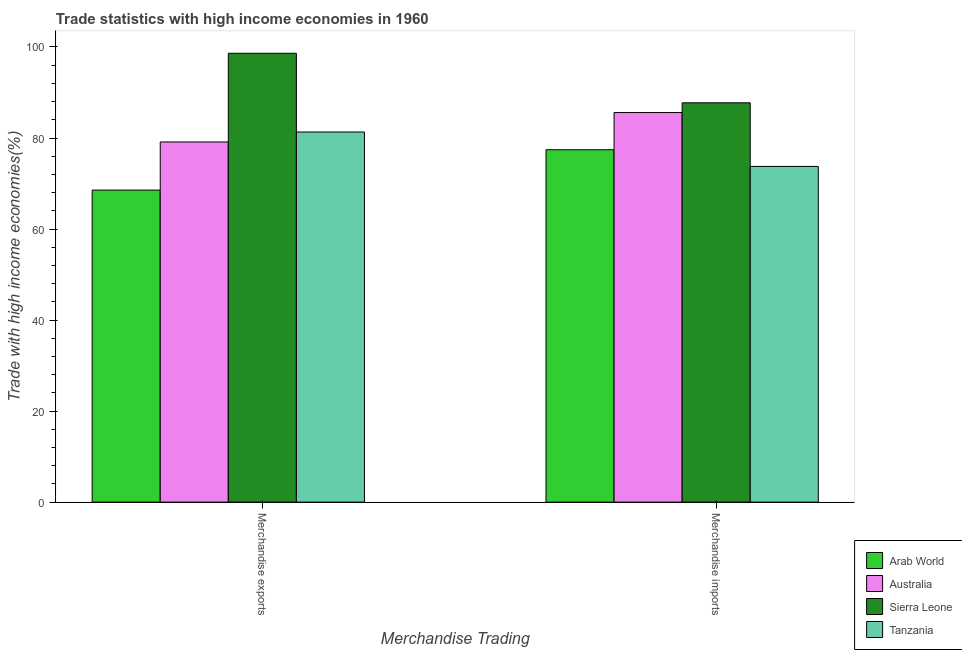How many groups of bars are there?
Provide a short and direct response. 2. How many bars are there on the 2nd tick from the right?
Your answer should be very brief. 4. What is the merchandise exports in Sierra Leone?
Give a very brief answer. 98.62. Across all countries, what is the maximum merchandise imports?
Offer a terse response. 87.74. Across all countries, what is the minimum merchandise exports?
Your response must be concise. 68.56. In which country was the merchandise imports maximum?
Provide a short and direct response. Sierra Leone. In which country was the merchandise imports minimum?
Provide a succinct answer. Tanzania. What is the total merchandise imports in the graph?
Offer a terse response. 324.53. What is the difference between the merchandise imports in Australia and that in Tanzania?
Offer a very short reply. 11.84. What is the difference between the merchandise imports in Sierra Leone and the merchandise exports in Tanzania?
Provide a short and direct response. 6.42. What is the average merchandise exports per country?
Offer a terse response. 81.91. What is the difference between the merchandise exports and merchandise imports in Tanzania?
Keep it short and to the point. 7.56. In how many countries, is the merchandise exports greater than 4 %?
Make the answer very short. 4. What is the ratio of the merchandise imports in Tanzania to that in Australia?
Ensure brevity in your answer.  0.86. Is the merchandise exports in Tanzania less than that in Sierra Leone?
Offer a very short reply. Yes. In how many countries, is the merchandise imports greater than the average merchandise imports taken over all countries?
Ensure brevity in your answer.  2. What does the 4th bar from the left in Merchandise imports represents?
Keep it short and to the point. Tanzania. What is the difference between two consecutive major ticks on the Y-axis?
Offer a terse response. 20. Does the graph contain grids?
Make the answer very short. No. Where does the legend appear in the graph?
Provide a succinct answer. Bottom right. What is the title of the graph?
Make the answer very short. Trade statistics with high income economies in 1960. Does "Sweden" appear as one of the legend labels in the graph?
Make the answer very short. No. What is the label or title of the X-axis?
Your response must be concise. Merchandise Trading. What is the label or title of the Y-axis?
Offer a terse response. Trade with high income economies(%). What is the Trade with high income economies(%) of Arab World in Merchandise exports?
Make the answer very short. 68.56. What is the Trade with high income economies(%) of Australia in Merchandise exports?
Your response must be concise. 79.13. What is the Trade with high income economies(%) of Sierra Leone in Merchandise exports?
Make the answer very short. 98.62. What is the Trade with high income economies(%) of Tanzania in Merchandise exports?
Ensure brevity in your answer.  81.32. What is the Trade with high income economies(%) in Arab World in Merchandise imports?
Provide a succinct answer. 77.43. What is the Trade with high income economies(%) of Australia in Merchandise imports?
Your answer should be compact. 85.6. What is the Trade with high income economies(%) in Sierra Leone in Merchandise imports?
Provide a short and direct response. 87.74. What is the Trade with high income economies(%) in Tanzania in Merchandise imports?
Offer a terse response. 73.76. Across all Merchandise Trading, what is the maximum Trade with high income economies(%) of Arab World?
Make the answer very short. 77.43. Across all Merchandise Trading, what is the maximum Trade with high income economies(%) in Australia?
Provide a succinct answer. 85.6. Across all Merchandise Trading, what is the maximum Trade with high income economies(%) of Sierra Leone?
Your answer should be compact. 98.62. Across all Merchandise Trading, what is the maximum Trade with high income economies(%) of Tanzania?
Your answer should be very brief. 81.32. Across all Merchandise Trading, what is the minimum Trade with high income economies(%) of Arab World?
Offer a very short reply. 68.56. Across all Merchandise Trading, what is the minimum Trade with high income economies(%) of Australia?
Ensure brevity in your answer.  79.13. Across all Merchandise Trading, what is the minimum Trade with high income economies(%) in Sierra Leone?
Your response must be concise. 87.74. Across all Merchandise Trading, what is the minimum Trade with high income economies(%) in Tanzania?
Offer a very short reply. 73.76. What is the total Trade with high income economies(%) in Arab World in the graph?
Your answer should be very brief. 145.99. What is the total Trade with high income economies(%) in Australia in the graph?
Provide a short and direct response. 164.73. What is the total Trade with high income economies(%) in Sierra Leone in the graph?
Give a very brief answer. 186.36. What is the total Trade with high income economies(%) of Tanzania in the graph?
Keep it short and to the point. 155.08. What is the difference between the Trade with high income economies(%) in Arab World in Merchandise exports and that in Merchandise imports?
Provide a succinct answer. -8.87. What is the difference between the Trade with high income economies(%) of Australia in Merchandise exports and that in Merchandise imports?
Offer a terse response. -6.47. What is the difference between the Trade with high income economies(%) of Sierra Leone in Merchandise exports and that in Merchandise imports?
Provide a succinct answer. 10.88. What is the difference between the Trade with high income economies(%) in Tanzania in Merchandise exports and that in Merchandise imports?
Ensure brevity in your answer.  7.56. What is the difference between the Trade with high income economies(%) of Arab World in Merchandise exports and the Trade with high income economies(%) of Australia in Merchandise imports?
Keep it short and to the point. -17.04. What is the difference between the Trade with high income economies(%) of Arab World in Merchandise exports and the Trade with high income economies(%) of Sierra Leone in Merchandise imports?
Make the answer very short. -19.18. What is the difference between the Trade with high income economies(%) in Arab World in Merchandise exports and the Trade with high income economies(%) in Tanzania in Merchandise imports?
Give a very brief answer. -5.2. What is the difference between the Trade with high income economies(%) of Australia in Merchandise exports and the Trade with high income economies(%) of Sierra Leone in Merchandise imports?
Your answer should be very brief. -8.61. What is the difference between the Trade with high income economies(%) in Australia in Merchandise exports and the Trade with high income economies(%) in Tanzania in Merchandise imports?
Give a very brief answer. 5.37. What is the difference between the Trade with high income economies(%) in Sierra Leone in Merchandise exports and the Trade with high income economies(%) in Tanzania in Merchandise imports?
Provide a succinct answer. 24.86. What is the average Trade with high income economies(%) of Arab World per Merchandise Trading?
Make the answer very short. 72.99. What is the average Trade with high income economies(%) of Australia per Merchandise Trading?
Your answer should be very brief. 82.37. What is the average Trade with high income economies(%) in Sierra Leone per Merchandise Trading?
Provide a short and direct response. 93.18. What is the average Trade with high income economies(%) of Tanzania per Merchandise Trading?
Provide a short and direct response. 77.54. What is the difference between the Trade with high income economies(%) of Arab World and Trade with high income economies(%) of Australia in Merchandise exports?
Give a very brief answer. -10.57. What is the difference between the Trade with high income economies(%) of Arab World and Trade with high income economies(%) of Sierra Leone in Merchandise exports?
Keep it short and to the point. -30.06. What is the difference between the Trade with high income economies(%) in Arab World and Trade with high income economies(%) in Tanzania in Merchandise exports?
Your response must be concise. -12.76. What is the difference between the Trade with high income economies(%) in Australia and Trade with high income economies(%) in Sierra Leone in Merchandise exports?
Offer a terse response. -19.49. What is the difference between the Trade with high income economies(%) of Australia and Trade with high income economies(%) of Tanzania in Merchandise exports?
Keep it short and to the point. -2.19. What is the difference between the Trade with high income economies(%) of Sierra Leone and Trade with high income economies(%) of Tanzania in Merchandise exports?
Make the answer very short. 17.3. What is the difference between the Trade with high income economies(%) in Arab World and Trade with high income economies(%) in Australia in Merchandise imports?
Provide a short and direct response. -8.18. What is the difference between the Trade with high income economies(%) of Arab World and Trade with high income economies(%) of Sierra Leone in Merchandise imports?
Provide a succinct answer. -10.32. What is the difference between the Trade with high income economies(%) of Arab World and Trade with high income economies(%) of Tanzania in Merchandise imports?
Your answer should be very brief. 3.67. What is the difference between the Trade with high income economies(%) of Australia and Trade with high income economies(%) of Sierra Leone in Merchandise imports?
Your response must be concise. -2.14. What is the difference between the Trade with high income economies(%) of Australia and Trade with high income economies(%) of Tanzania in Merchandise imports?
Your response must be concise. 11.84. What is the difference between the Trade with high income economies(%) in Sierra Leone and Trade with high income economies(%) in Tanzania in Merchandise imports?
Give a very brief answer. 13.98. What is the ratio of the Trade with high income economies(%) of Arab World in Merchandise exports to that in Merchandise imports?
Provide a succinct answer. 0.89. What is the ratio of the Trade with high income economies(%) in Australia in Merchandise exports to that in Merchandise imports?
Provide a short and direct response. 0.92. What is the ratio of the Trade with high income economies(%) of Sierra Leone in Merchandise exports to that in Merchandise imports?
Your answer should be very brief. 1.12. What is the ratio of the Trade with high income economies(%) of Tanzania in Merchandise exports to that in Merchandise imports?
Offer a very short reply. 1.1. What is the difference between the highest and the second highest Trade with high income economies(%) in Arab World?
Give a very brief answer. 8.87. What is the difference between the highest and the second highest Trade with high income economies(%) in Australia?
Your answer should be compact. 6.47. What is the difference between the highest and the second highest Trade with high income economies(%) of Sierra Leone?
Ensure brevity in your answer.  10.88. What is the difference between the highest and the second highest Trade with high income economies(%) of Tanzania?
Make the answer very short. 7.56. What is the difference between the highest and the lowest Trade with high income economies(%) in Arab World?
Make the answer very short. 8.87. What is the difference between the highest and the lowest Trade with high income economies(%) in Australia?
Keep it short and to the point. 6.47. What is the difference between the highest and the lowest Trade with high income economies(%) of Sierra Leone?
Ensure brevity in your answer.  10.88. What is the difference between the highest and the lowest Trade with high income economies(%) in Tanzania?
Keep it short and to the point. 7.56. 